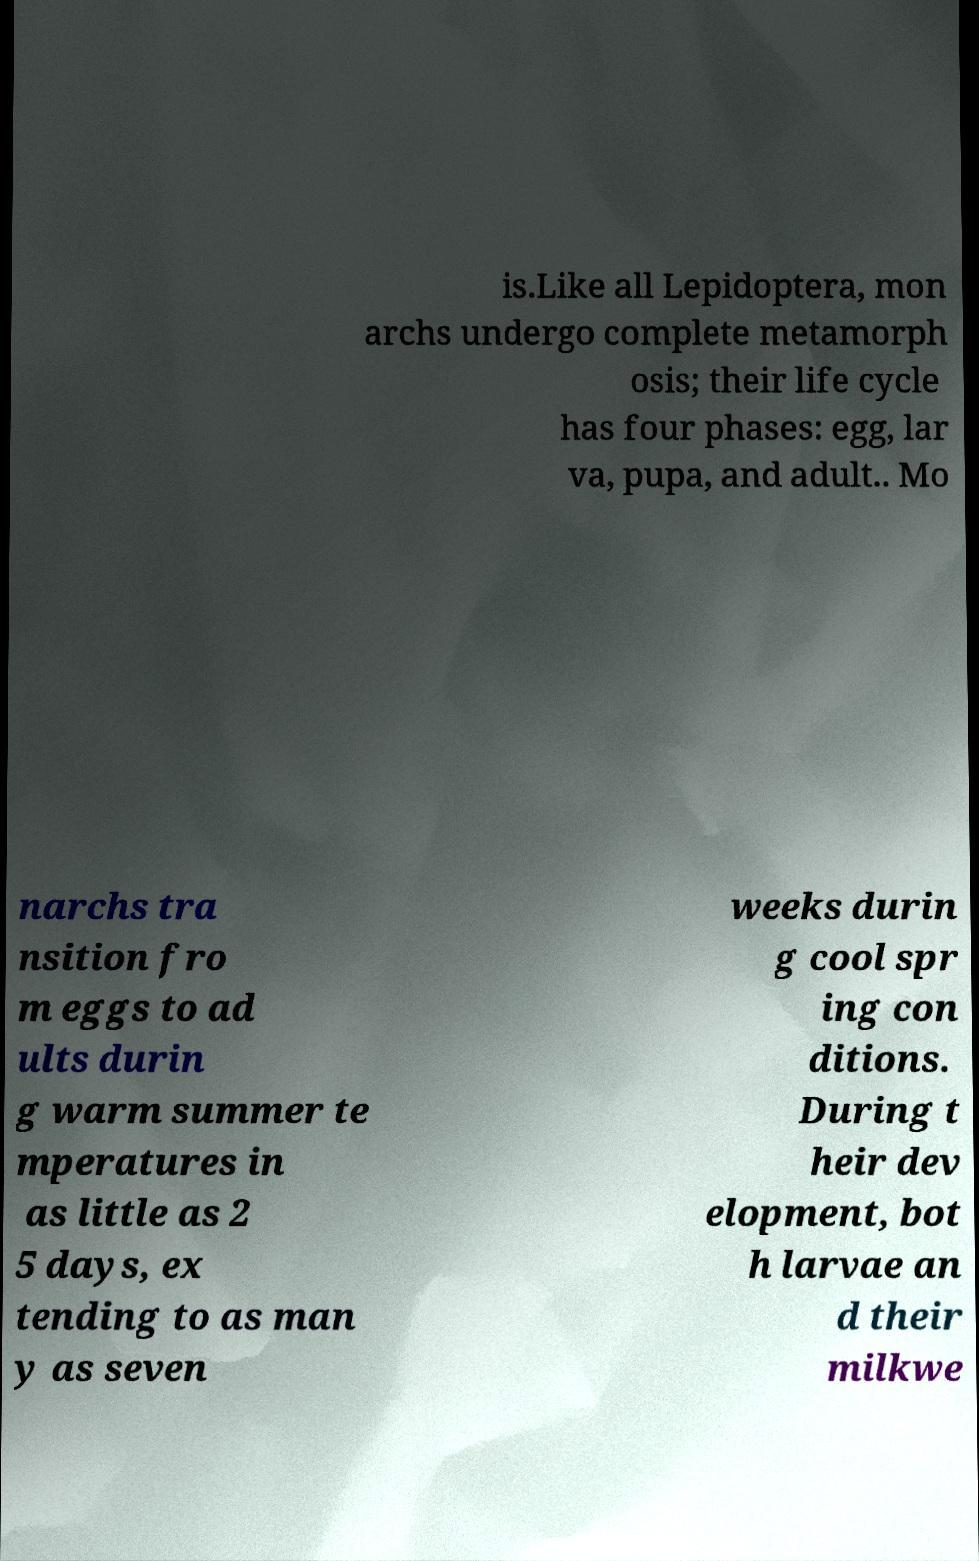Could you extract and type out the text from this image? is.Like all Lepidoptera, mon archs undergo complete metamorph osis; their life cycle has four phases: egg, lar va, pupa, and adult.. Mo narchs tra nsition fro m eggs to ad ults durin g warm summer te mperatures in as little as 2 5 days, ex tending to as man y as seven weeks durin g cool spr ing con ditions. During t heir dev elopment, bot h larvae an d their milkwe 